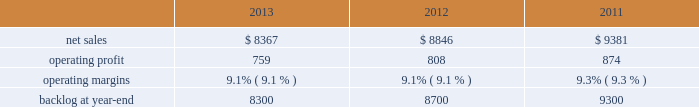Aeronautics 2019 operating profit for 2012 increased $ 69 million , or 4% ( 4 % ) , compared to 2011 .
The increase was attributable to higher operating profit of approximately $ 105 million from c-130 programs due to an increase in risk retirements ; about $ 50 million from f-16 programs due to higher aircraft deliveries partially offset by a decline in risk retirements ; approximately $ 50 million from f-35 production contracts due to increased production volume and risk retirements ; and about $ 50 million from the completion of purchased intangible asset amortization on certain f-16 contracts .
Partially offsetting the increases was lower operating profit of about $ 90 million from the f-35 development contract primarily due to the inception-to-date effect of reducing the profit booking rate in the second quarter of 2012 ; approximately $ 50 million from decreased production volume and risk retirements on the f-22 program partially offset by a resolution of a contractual matter in the second quarter of 2012 ; and approximately $ 45 million primarily due to a decrease in risk retirements on other sustainment activities partially offset by various other aeronautics programs due to increased risk retirements and volume .
Operating profit for c-5 programs was comparable to 2011 .
Adjustments not related to volume , including net profit booking rate adjustments and other matters described above , were approximately $ 30 million lower for 2012 compared to 2011 .
Backlog backlog decreased in 2013 compared to 2012 mainly due to lower orders on f-16 , c-5 , and c-130 programs , partially offset by higher orders on the f-35 program .
Backlog decreased in 2012 compared to 2011 mainly due to lower orders on f-35 and c-130 programs , partially offset by higher orders on f-16 programs .
Trends we expect aeronautics 2019 net sales to increase in 2014 in the mid-single digit percentage range as compared to 2013 primarily due to an increase in net sales from f-35 production contracts .
Operating profit is expected to increase slightly from 2013 , resulting in a slight decrease in operating margins between the years due to program mix .
Information systems & global solutions our is&gs business segment provides advanced technology systems and expertise , integrated information technology solutions , and management services across a broad spectrum of applications for civil , defense , intelligence , and other government customers .
Is&gs has a portfolio of many smaller contracts as compared to our other business segments .
Is&gs has been impacted by the continued downturn in federal information technology budgets .
Is&gs 2019 operating results included the following ( in millions ) : .
2013 compared to 2012 is&gs 2019 net sales decreased $ 479 million , or 5% ( 5 % ) , for 2013 compared to 2012 .
The decrease was attributable to lower net sales of about $ 495 million due to decreased volume on various programs ( command and control programs for classified customers , ngi , and eram programs ) ; and approximately $ 320 million due to the completion of certain programs ( such as total information processing support services , the transportation worker identification credential ( twic ) , and odin ) .
The decrease was partially offset by higher net sales of about $ 340 million due to the start-up of certain programs ( such as the disa gsm-o and the national science foundation antarctic support ) .
Is&gs 2019 operating profit decreased $ 49 million , or 6% ( 6 % ) , for 2013 compared to 2012 .
The decrease was primarily attributable to lower operating profit of about $ 55 million due to certain programs nearing the end of their lifecycles , partially offset by higher operating profit of approximately $ 15 million due to the start-up of certain programs .
Adjustments not related to volume , including net profit booking rate adjustments and other matters , were comparable for 2013 compared to 2012 compared to 2011 is&gs 2019 net sales for 2012 decreased $ 535 million , or 6% ( 6 % ) , compared to 2011 .
The decrease was attributable to lower net sales of approximately $ 485 million due to the substantial completion of various programs during 2011 ( primarily jtrs ; odin ; and u.k .
Census ) ; and about $ 255 million due to lower volume on numerous other programs ( primarily hanford; .
As part of the is&gs results of operation what as the average operating profit from 2011 to 2013? 
Computations: (((759 + 808) + 874) / 3)
Answer: 813.66667. 